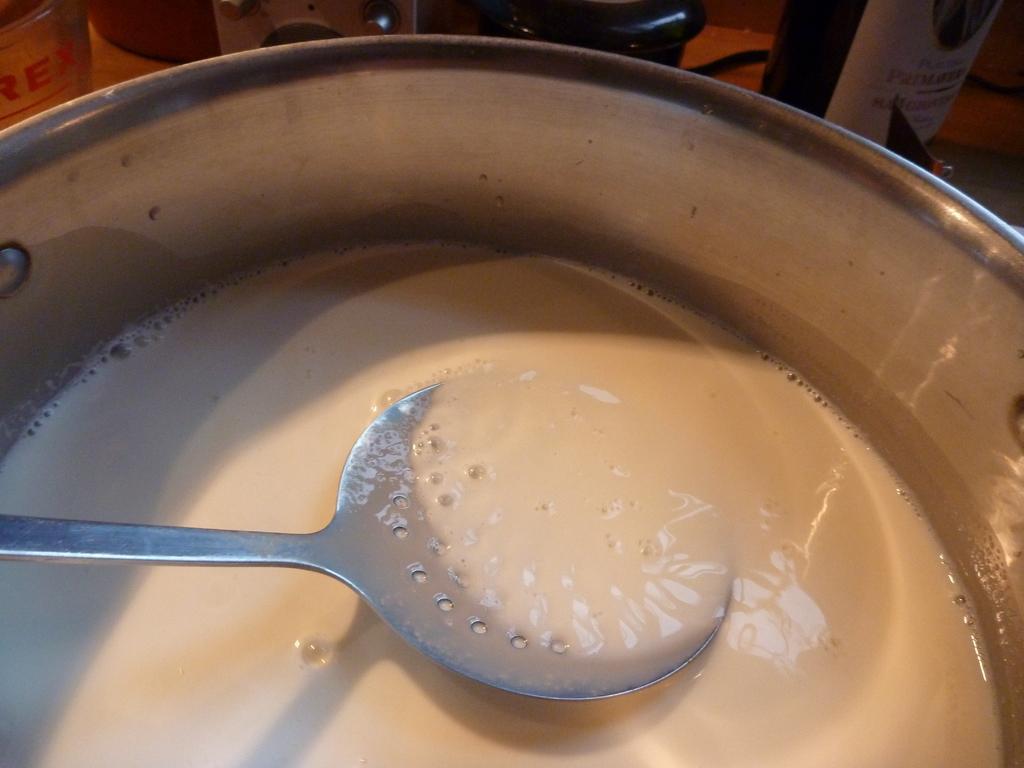Please provide a concise description of this image. In this image, I can see a bowl which consists of milk and there is a spoon. At the top of the image there are two bottles and some other objects. 